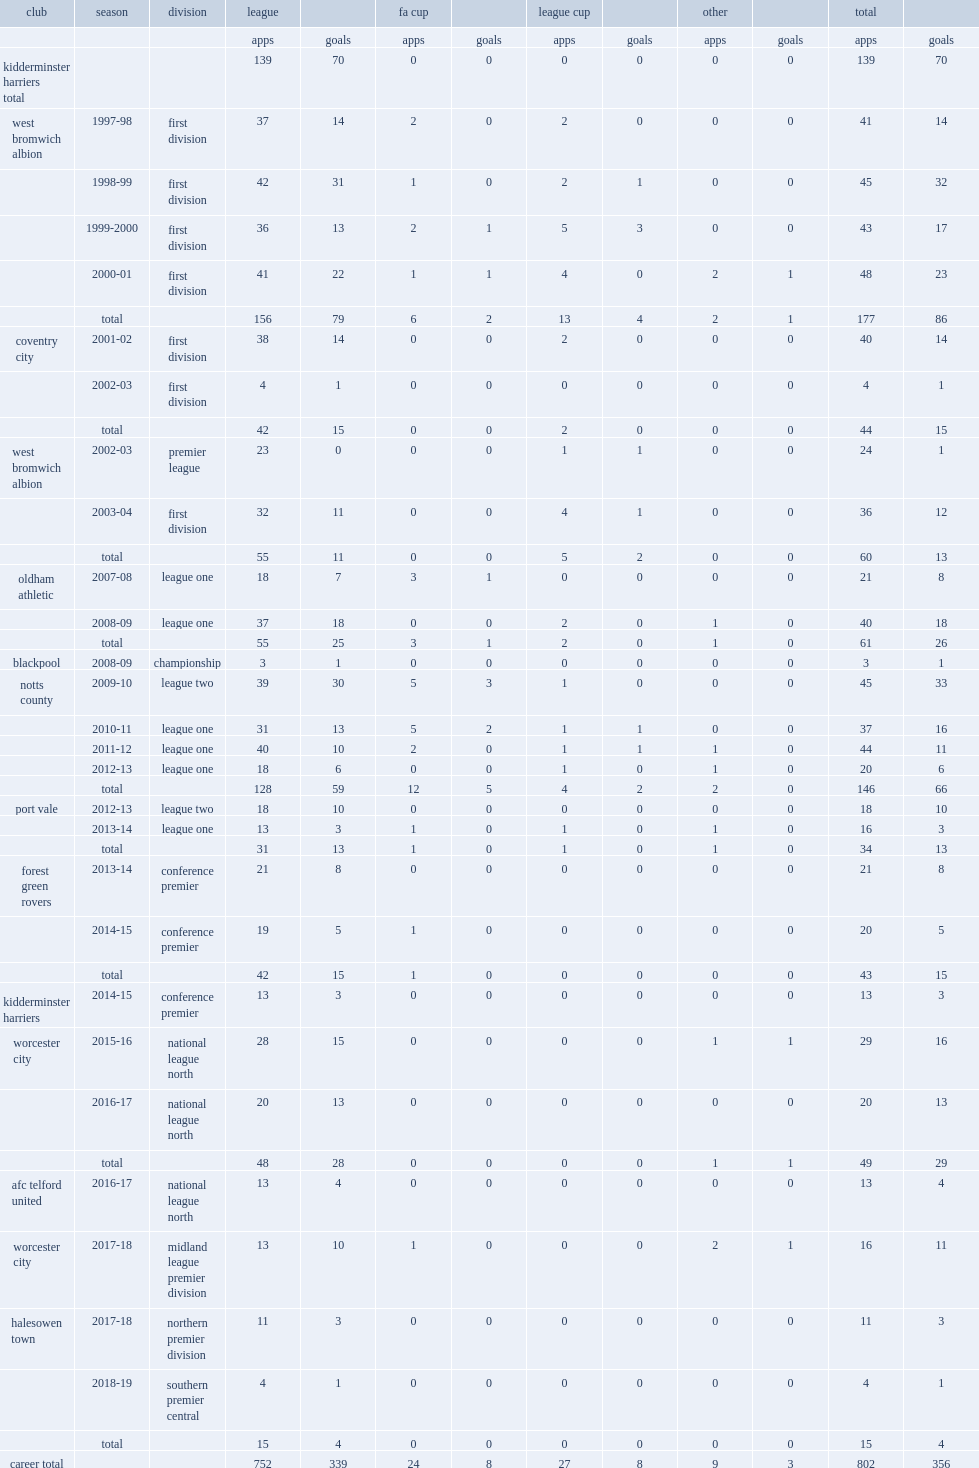How many league goals did lee hughes score for notts county in 2009. 30.0. Could you parse the entire table? {'header': ['club', 'season', 'division', 'league', '', 'fa cup', '', 'league cup', '', 'other', '', 'total', ''], 'rows': [['', '', '', 'apps', 'goals', 'apps', 'goals', 'apps', 'goals', 'apps', 'goals', 'apps', 'goals'], ['kidderminster harriers total', '', '', '139', '70', '0', '0', '0', '0', '0', '0', '139', '70'], ['west bromwich albion', '1997-98', 'first division', '37', '14', '2', '0', '2', '0', '0', '0', '41', '14'], ['', '1998-99', 'first division', '42', '31', '1', '0', '2', '1', '0', '0', '45', '32'], ['', '1999-2000', 'first division', '36', '13', '2', '1', '5', '3', '0', '0', '43', '17'], ['', '2000-01', 'first division', '41', '22', '1', '1', '4', '0', '2', '1', '48', '23'], ['', 'total', '', '156', '79', '6', '2', '13', '4', '2', '1', '177', '86'], ['coventry city', '2001-02', 'first division', '38', '14', '0', '0', '2', '0', '0', '0', '40', '14'], ['', '2002-03', 'first division', '4', '1', '0', '0', '0', '0', '0', '0', '4', '1'], ['', 'total', '', '42', '15', '0', '0', '2', '0', '0', '0', '44', '15'], ['west bromwich albion', '2002-03', 'premier league', '23', '0', '0', '0', '1', '1', '0', '0', '24', '1'], ['', '2003-04', 'first division', '32', '11', '0', '0', '4', '1', '0', '0', '36', '12'], ['', 'total', '', '55', '11', '0', '0', '5', '2', '0', '0', '60', '13'], ['oldham athletic', '2007-08', 'league one', '18', '7', '3', '1', '0', '0', '0', '0', '21', '8'], ['', '2008-09', 'league one', '37', '18', '0', '0', '2', '0', '1', '0', '40', '18'], ['', 'total', '', '55', '25', '3', '1', '2', '0', '1', '0', '61', '26'], ['blackpool', '2008-09', 'championship', '3', '1', '0', '0', '0', '0', '0', '0', '3', '1'], ['notts county', '2009-10', 'league two', '39', '30', '5', '3', '1', '0', '0', '0', '45', '33'], ['', '2010-11', 'league one', '31', '13', '5', '2', '1', '1', '0', '0', '37', '16'], ['', '2011-12', 'league one', '40', '10', '2', '0', '1', '1', '1', '0', '44', '11'], ['', '2012-13', 'league one', '18', '6', '0', '0', '1', '0', '1', '0', '20', '6'], ['', 'total', '', '128', '59', '12', '5', '4', '2', '2', '0', '146', '66'], ['port vale', '2012-13', 'league two', '18', '10', '0', '0', '0', '0', '0', '0', '18', '10'], ['', '2013-14', 'league one', '13', '3', '1', '0', '1', '0', '1', '0', '16', '3'], ['', 'total', '', '31', '13', '1', '0', '1', '0', '1', '0', '34', '13'], ['forest green rovers', '2013-14', 'conference premier', '21', '8', '0', '0', '0', '0', '0', '0', '21', '8'], ['', '2014-15', 'conference premier', '19', '5', '1', '0', '0', '0', '0', '0', '20', '5'], ['', 'total', '', '42', '15', '1', '0', '0', '0', '0', '0', '43', '15'], ['kidderminster harriers', '2014-15', 'conference premier', '13', '3', '0', '0', '0', '0', '0', '0', '13', '3'], ['worcester city', '2015-16', 'national league north', '28', '15', '0', '0', '0', '0', '1', '1', '29', '16'], ['', '2016-17', 'national league north', '20', '13', '0', '0', '0', '0', '0', '0', '20', '13'], ['', 'total', '', '48', '28', '0', '0', '0', '0', '1', '1', '49', '29'], ['afc telford united', '2016-17', 'national league north', '13', '4', '0', '0', '0', '0', '0', '0', '13', '4'], ['worcester city', '2017-18', 'midland league premier division', '13', '10', '1', '0', '0', '0', '2', '1', '16', '11'], ['halesowen town', '2017-18', 'northern premier division', '11', '3', '0', '0', '0', '0', '0', '0', '11', '3'], ['', '2018-19', 'southern premier central', '4', '1', '0', '0', '0', '0', '0', '0', '4', '1'], ['', 'total', '', '15', '4', '0', '0', '0', '0', '0', '0', '15', '4'], ['career total', '', '', '752', '339', '24', '8', '27', '8', '9', '3', '802', '356']]} Which club did lee hughes play for in 2012-13? Port vale. 